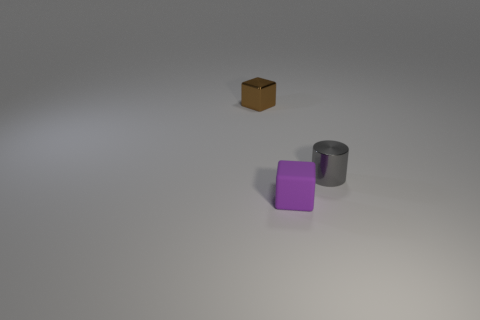Subtract 1 cylinders. How many cylinders are left? 0 Add 2 tiny objects. How many objects exist? 5 Subtract all blue cylinders. Subtract all red spheres. How many cylinders are left? 1 Subtract all green balls. How many brown cubes are left? 1 Subtract all green shiny cylinders. Subtract all tiny purple rubber blocks. How many objects are left? 2 Add 2 blocks. How many blocks are left? 4 Add 3 gray cylinders. How many gray cylinders exist? 4 Subtract 0 blue spheres. How many objects are left? 3 Subtract all cylinders. How many objects are left? 2 